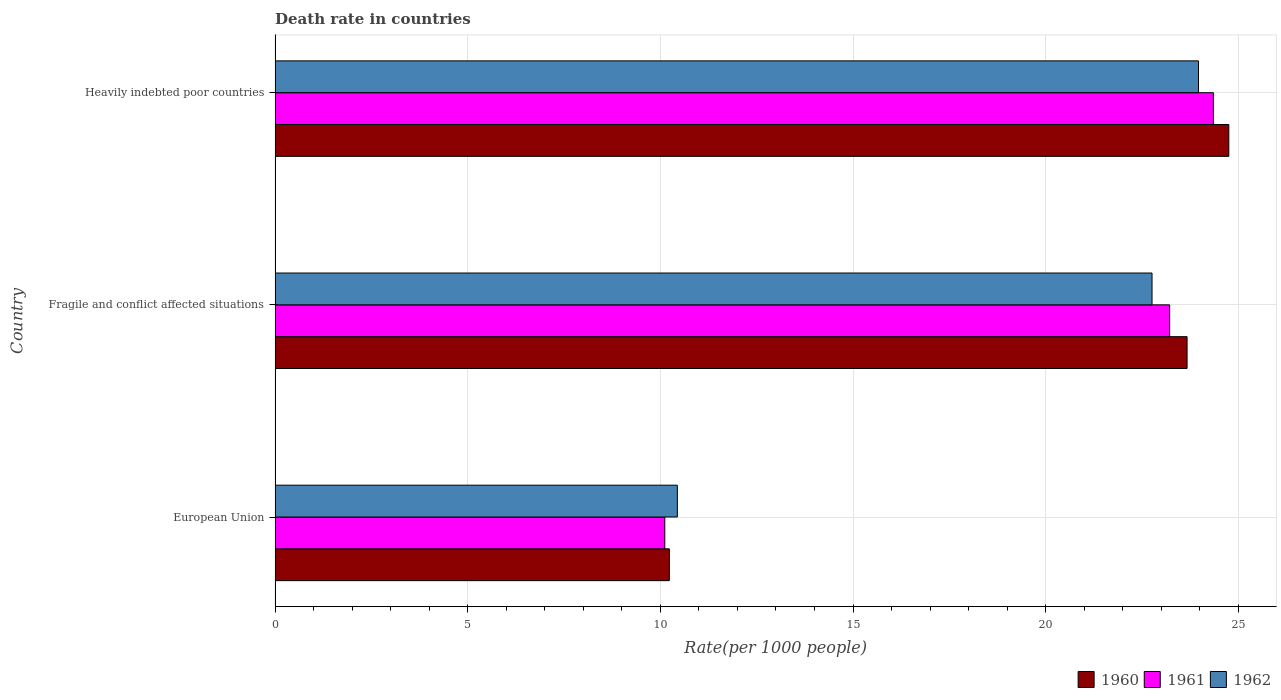How many different coloured bars are there?
Make the answer very short. 3. Are the number of bars per tick equal to the number of legend labels?
Offer a terse response. Yes. How many bars are there on the 1st tick from the top?
Provide a succinct answer. 3. What is the label of the 1st group of bars from the top?
Your answer should be compact. Heavily indebted poor countries. In how many cases, is the number of bars for a given country not equal to the number of legend labels?
Offer a terse response. 0. What is the death rate in 1962 in Fragile and conflict affected situations?
Your response must be concise. 22.76. Across all countries, what is the maximum death rate in 1960?
Ensure brevity in your answer.  24.75. Across all countries, what is the minimum death rate in 1961?
Your answer should be compact. 10.11. In which country was the death rate in 1962 maximum?
Your answer should be very brief. Heavily indebted poor countries. In which country was the death rate in 1961 minimum?
Your answer should be compact. European Union. What is the total death rate in 1962 in the graph?
Offer a terse response. 57.17. What is the difference between the death rate in 1962 in European Union and that in Fragile and conflict affected situations?
Ensure brevity in your answer.  -12.32. What is the difference between the death rate in 1962 in Heavily indebted poor countries and the death rate in 1961 in European Union?
Offer a terse response. 13.85. What is the average death rate in 1962 per country?
Offer a terse response. 19.06. What is the difference between the death rate in 1960 and death rate in 1961 in Heavily indebted poor countries?
Give a very brief answer. 0.4. What is the ratio of the death rate in 1961 in Fragile and conflict affected situations to that in Heavily indebted poor countries?
Provide a short and direct response. 0.95. Is the death rate in 1960 in European Union less than that in Heavily indebted poor countries?
Make the answer very short. Yes. What is the difference between the highest and the second highest death rate in 1961?
Make the answer very short. 1.13. What is the difference between the highest and the lowest death rate in 1962?
Keep it short and to the point. 13.53. In how many countries, is the death rate in 1961 greater than the average death rate in 1961 taken over all countries?
Your response must be concise. 2. What does the 1st bar from the top in Fragile and conflict affected situations represents?
Provide a short and direct response. 1962. What does the 3rd bar from the bottom in Heavily indebted poor countries represents?
Give a very brief answer. 1962. Is it the case that in every country, the sum of the death rate in 1962 and death rate in 1960 is greater than the death rate in 1961?
Your answer should be compact. Yes. How many bars are there?
Offer a very short reply. 9. What is the difference between two consecutive major ticks on the X-axis?
Your response must be concise. 5. Are the values on the major ticks of X-axis written in scientific E-notation?
Your answer should be compact. No. How many legend labels are there?
Keep it short and to the point. 3. How are the legend labels stacked?
Give a very brief answer. Horizontal. What is the title of the graph?
Provide a succinct answer. Death rate in countries. What is the label or title of the X-axis?
Offer a very short reply. Rate(per 1000 people). What is the Rate(per 1000 people) of 1960 in European Union?
Offer a terse response. 10.23. What is the Rate(per 1000 people) in 1961 in European Union?
Give a very brief answer. 10.11. What is the Rate(per 1000 people) of 1962 in European Union?
Make the answer very short. 10.44. What is the Rate(per 1000 people) of 1960 in Fragile and conflict affected situations?
Provide a succinct answer. 23.67. What is the Rate(per 1000 people) of 1961 in Fragile and conflict affected situations?
Your answer should be compact. 23.22. What is the Rate(per 1000 people) of 1962 in Fragile and conflict affected situations?
Offer a very short reply. 22.76. What is the Rate(per 1000 people) in 1960 in Heavily indebted poor countries?
Ensure brevity in your answer.  24.75. What is the Rate(per 1000 people) in 1961 in Heavily indebted poor countries?
Your response must be concise. 24.35. What is the Rate(per 1000 people) in 1962 in Heavily indebted poor countries?
Make the answer very short. 23.97. Across all countries, what is the maximum Rate(per 1000 people) in 1960?
Ensure brevity in your answer.  24.75. Across all countries, what is the maximum Rate(per 1000 people) of 1961?
Provide a succinct answer. 24.35. Across all countries, what is the maximum Rate(per 1000 people) of 1962?
Your answer should be very brief. 23.97. Across all countries, what is the minimum Rate(per 1000 people) of 1960?
Your response must be concise. 10.23. Across all countries, what is the minimum Rate(per 1000 people) of 1961?
Make the answer very short. 10.11. Across all countries, what is the minimum Rate(per 1000 people) in 1962?
Offer a terse response. 10.44. What is the total Rate(per 1000 people) of 1960 in the graph?
Provide a short and direct response. 58.66. What is the total Rate(per 1000 people) of 1961 in the graph?
Offer a terse response. 57.69. What is the total Rate(per 1000 people) in 1962 in the graph?
Offer a very short reply. 57.17. What is the difference between the Rate(per 1000 people) of 1960 in European Union and that in Fragile and conflict affected situations?
Your answer should be compact. -13.44. What is the difference between the Rate(per 1000 people) in 1961 in European Union and that in Fragile and conflict affected situations?
Offer a very short reply. -13.1. What is the difference between the Rate(per 1000 people) in 1962 in European Union and that in Fragile and conflict affected situations?
Give a very brief answer. -12.32. What is the difference between the Rate(per 1000 people) of 1960 in European Union and that in Heavily indebted poor countries?
Your answer should be very brief. -14.52. What is the difference between the Rate(per 1000 people) in 1961 in European Union and that in Heavily indebted poor countries?
Your answer should be very brief. -14.24. What is the difference between the Rate(per 1000 people) in 1962 in European Union and that in Heavily indebted poor countries?
Keep it short and to the point. -13.53. What is the difference between the Rate(per 1000 people) in 1960 in Fragile and conflict affected situations and that in Heavily indebted poor countries?
Provide a short and direct response. -1.08. What is the difference between the Rate(per 1000 people) of 1961 in Fragile and conflict affected situations and that in Heavily indebted poor countries?
Provide a succinct answer. -1.13. What is the difference between the Rate(per 1000 people) in 1962 in Fragile and conflict affected situations and that in Heavily indebted poor countries?
Ensure brevity in your answer.  -1.21. What is the difference between the Rate(per 1000 people) in 1960 in European Union and the Rate(per 1000 people) in 1961 in Fragile and conflict affected situations?
Your answer should be very brief. -12.99. What is the difference between the Rate(per 1000 people) of 1960 in European Union and the Rate(per 1000 people) of 1962 in Fragile and conflict affected situations?
Give a very brief answer. -12.53. What is the difference between the Rate(per 1000 people) of 1961 in European Union and the Rate(per 1000 people) of 1962 in Fragile and conflict affected situations?
Your response must be concise. -12.65. What is the difference between the Rate(per 1000 people) of 1960 in European Union and the Rate(per 1000 people) of 1961 in Heavily indebted poor countries?
Ensure brevity in your answer.  -14.12. What is the difference between the Rate(per 1000 people) of 1960 in European Union and the Rate(per 1000 people) of 1962 in Heavily indebted poor countries?
Give a very brief answer. -13.73. What is the difference between the Rate(per 1000 people) of 1961 in European Union and the Rate(per 1000 people) of 1962 in Heavily indebted poor countries?
Provide a succinct answer. -13.85. What is the difference between the Rate(per 1000 people) of 1960 in Fragile and conflict affected situations and the Rate(per 1000 people) of 1961 in Heavily indebted poor countries?
Provide a short and direct response. -0.68. What is the difference between the Rate(per 1000 people) of 1960 in Fragile and conflict affected situations and the Rate(per 1000 people) of 1962 in Heavily indebted poor countries?
Provide a succinct answer. -0.3. What is the difference between the Rate(per 1000 people) of 1961 in Fragile and conflict affected situations and the Rate(per 1000 people) of 1962 in Heavily indebted poor countries?
Provide a succinct answer. -0.75. What is the average Rate(per 1000 people) of 1960 per country?
Give a very brief answer. 19.55. What is the average Rate(per 1000 people) of 1961 per country?
Your answer should be very brief. 19.23. What is the average Rate(per 1000 people) in 1962 per country?
Offer a terse response. 19.06. What is the difference between the Rate(per 1000 people) of 1960 and Rate(per 1000 people) of 1961 in European Union?
Offer a very short reply. 0.12. What is the difference between the Rate(per 1000 people) in 1960 and Rate(per 1000 people) in 1962 in European Union?
Your answer should be very brief. -0.21. What is the difference between the Rate(per 1000 people) of 1961 and Rate(per 1000 people) of 1962 in European Union?
Your answer should be very brief. -0.33. What is the difference between the Rate(per 1000 people) in 1960 and Rate(per 1000 people) in 1961 in Fragile and conflict affected situations?
Keep it short and to the point. 0.45. What is the difference between the Rate(per 1000 people) in 1960 and Rate(per 1000 people) in 1962 in Fragile and conflict affected situations?
Your answer should be compact. 0.91. What is the difference between the Rate(per 1000 people) in 1961 and Rate(per 1000 people) in 1962 in Fragile and conflict affected situations?
Keep it short and to the point. 0.46. What is the difference between the Rate(per 1000 people) of 1960 and Rate(per 1000 people) of 1961 in Heavily indebted poor countries?
Give a very brief answer. 0.4. What is the difference between the Rate(per 1000 people) of 1960 and Rate(per 1000 people) of 1962 in Heavily indebted poor countries?
Your response must be concise. 0.79. What is the difference between the Rate(per 1000 people) of 1961 and Rate(per 1000 people) of 1962 in Heavily indebted poor countries?
Make the answer very short. 0.39. What is the ratio of the Rate(per 1000 people) in 1960 in European Union to that in Fragile and conflict affected situations?
Give a very brief answer. 0.43. What is the ratio of the Rate(per 1000 people) of 1961 in European Union to that in Fragile and conflict affected situations?
Keep it short and to the point. 0.44. What is the ratio of the Rate(per 1000 people) of 1962 in European Union to that in Fragile and conflict affected situations?
Offer a terse response. 0.46. What is the ratio of the Rate(per 1000 people) in 1960 in European Union to that in Heavily indebted poor countries?
Your response must be concise. 0.41. What is the ratio of the Rate(per 1000 people) in 1961 in European Union to that in Heavily indebted poor countries?
Give a very brief answer. 0.42. What is the ratio of the Rate(per 1000 people) of 1962 in European Union to that in Heavily indebted poor countries?
Your response must be concise. 0.44. What is the ratio of the Rate(per 1000 people) of 1960 in Fragile and conflict affected situations to that in Heavily indebted poor countries?
Provide a short and direct response. 0.96. What is the ratio of the Rate(per 1000 people) of 1961 in Fragile and conflict affected situations to that in Heavily indebted poor countries?
Offer a very short reply. 0.95. What is the ratio of the Rate(per 1000 people) in 1962 in Fragile and conflict affected situations to that in Heavily indebted poor countries?
Your answer should be very brief. 0.95. What is the difference between the highest and the second highest Rate(per 1000 people) in 1960?
Offer a very short reply. 1.08. What is the difference between the highest and the second highest Rate(per 1000 people) of 1961?
Offer a terse response. 1.13. What is the difference between the highest and the second highest Rate(per 1000 people) in 1962?
Offer a terse response. 1.21. What is the difference between the highest and the lowest Rate(per 1000 people) in 1960?
Your answer should be very brief. 14.52. What is the difference between the highest and the lowest Rate(per 1000 people) of 1961?
Give a very brief answer. 14.24. What is the difference between the highest and the lowest Rate(per 1000 people) of 1962?
Provide a succinct answer. 13.53. 